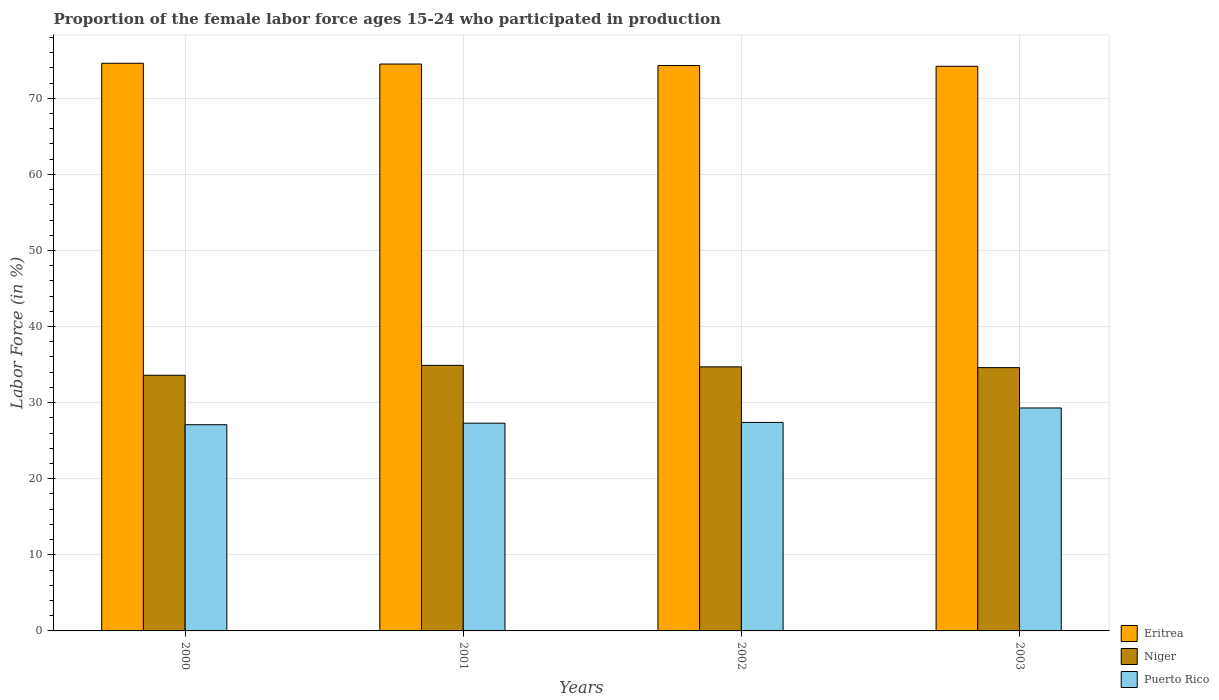How many groups of bars are there?
Make the answer very short. 4. Are the number of bars on each tick of the X-axis equal?
Offer a terse response. Yes. What is the label of the 4th group of bars from the left?
Your answer should be compact. 2003. What is the proportion of the female labor force who participated in production in Niger in 2000?
Offer a very short reply. 33.6. Across all years, what is the maximum proportion of the female labor force who participated in production in Eritrea?
Your response must be concise. 74.6. Across all years, what is the minimum proportion of the female labor force who participated in production in Puerto Rico?
Offer a very short reply. 27.1. What is the total proportion of the female labor force who participated in production in Puerto Rico in the graph?
Provide a short and direct response. 111.1. What is the difference between the proportion of the female labor force who participated in production in Niger in 2000 and that in 2003?
Give a very brief answer. -1. What is the difference between the proportion of the female labor force who participated in production in Puerto Rico in 2003 and the proportion of the female labor force who participated in production in Eritrea in 2002?
Give a very brief answer. -45. What is the average proportion of the female labor force who participated in production in Puerto Rico per year?
Your response must be concise. 27.77. In the year 2002, what is the difference between the proportion of the female labor force who participated in production in Puerto Rico and proportion of the female labor force who participated in production in Eritrea?
Give a very brief answer. -46.9. In how many years, is the proportion of the female labor force who participated in production in Niger greater than 32 %?
Keep it short and to the point. 4. What is the ratio of the proportion of the female labor force who participated in production in Eritrea in 2000 to that in 2002?
Ensure brevity in your answer.  1. What is the difference between the highest and the second highest proportion of the female labor force who participated in production in Niger?
Give a very brief answer. 0.2. What is the difference between the highest and the lowest proportion of the female labor force who participated in production in Niger?
Ensure brevity in your answer.  1.3. In how many years, is the proportion of the female labor force who participated in production in Eritrea greater than the average proportion of the female labor force who participated in production in Eritrea taken over all years?
Provide a succinct answer. 2. Is the sum of the proportion of the female labor force who participated in production in Niger in 2000 and 2002 greater than the maximum proportion of the female labor force who participated in production in Eritrea across all years?
Offer a terse response. No. What does the 3rd bar from the left in 2003 represents?
Your answer should be compact. Puerto Rico. What does the 2nd bar from the right in 2002 represents?
Offer a very short reply. Niger. Where does the legend appear in the graph?
Offer a terse response. Bottom right. What is the title of the graph?
Offer a very short reply. Proportion of the female labor force ages 15-24 who participated in production. What is the Labor Force (in %) of Eritrea in 2000?
Make the answer very short. 74.6. What is the Labor Force (in %) in Niger in 2000?
Provide a short and direct response. 33.6. What is the Labor Force (in %) of Puerto Rico in 2000?
Your answer should be compact. 27.1. What is the Labor Force (in %) in Eritrea in 2001?
Offer a terse response. 74.5. What is the Labor Force (in %) in Niger in 2001?
Provide a succinct answer. 34.9. What is the Labor Force (in %) of Puerto Rico in 2001?
Keep it short and to the point. 27.3. What is the Labor Force (in %) in Eritrea in 2002?
Ensure brevity in your answer.  74.3. What is the Labor Force (in %) in Niger in 2002?
Give a very brief answer. 34.7. What is the Labor Force (in %) in Puerto Rico in 2002?
Provide a short and direct response. 27.4. What is the Labor Force (in %) in Eritrea in 2003?
Offer a very short reply. 74.2. What is the Labor Force (in %) in Niger in 2003?
Your response must be concise. 34.6. What is the Labor Force (in %) in Puerto Rico in 2003?
Offer a terse response. 29.3. Across all years, what is the maximum Labor Force (in %) of Eritrea?
Keep it short and to the point. 74.6. Across all years, what is the maximum Labor Force (in %) of Niger?
Your answer should be compact. 34.9. Across all years, what is the maximum Labor Force (in %) in Puerto Rico?
Offer a terse response. 29.3. Across all years, what is the minimum Labor Force (in %) in Eritrea?
Offer a terse response. 74.2. Across all years, what is the minimum Labor Force (in %) in Niger?
Give a very brief answer. 33.6. Across all years, what is the minimum Labor Force (in %) of Puerto Rico?
Provide a short and direct response. 27.1. What is the total Labor Force (in %) of Eritrea in the graph?
Your answer should be compact. 297.6. What is the total Labor Force (in %) in Niger in the graph?
Keep it short and to the point. 137.8. What is the total Labor Force (in %) in Puerto Rico in the graph?
Provide a succinct answer. 111.1. What is the difference between the Labor Force (in %) of Eritrea in 2000 and that in 2001?
Your answer should be compact. 0.1. What is the difference between the Labor Force (in %) of Niger in 2000 and that in 2001?
Keep it short and to the point. -1.3. What is the difference between the Labor Force (in %) of Puerto Rico in 2000 and that in 2001?
Ensure brevity in your answer.  -0.2. What is the difference between the Labor Force (in %) of Eritrea in 2000 and that in 2002?
Keep it short and to the point. 0.3. What is the difference between the Labor Force (in %) of Niger in 2000 and that in 2002?
Offer a very short reply. -1.1. What is the difference between the Labor Force (in %) of Eritrea in 2000 and that in 2003?
Your response must be concise. 0.4. What is the difference between the Labor Force (in %) of Puerto Rico in 2000 and that in 2003?
Offer a very short reply. -2.2. What is the difference between the Labor Force (in %) in Eritrea in 2001 and that in 2002?
Offer a very short reply. 0.2. What is the difference between the Labor Force (in %) of Niger in 2001 and that in 2002?
Give a very brief answer. 0.2. What is the difference between the Labor Force (in %) of Puerto Rico in 2001 and that in 2002?
Provide a short and direct response. -0.1. What is the difference between the Labor Force (in %) in Puerto Rico in 2001 and that in 2003?
Your response must be concise. -2. What is the difference between the Labor Force (in %) of Niger in 2002 and that in 2003?
Your response must be concise. 0.1. What is the difference between the Labor Force (in %) in Puerto Rico in 2002 and that in 2003?
Your answer should be very brief. -1.9. What is the difference between the Labor Force (in %) in Eritrea in 2000 and the Labor Force (in %) in Niger in 2001?
Provide a short and direct response. 39.7. What is the difference between the Labor Force (in %) of Eritrea in 2000 and the Labor Force (in %) of Puerto Rico in 2001?
Make the answer very short. 47.3. What is the difference between the Labor Force (in %) in Niger in 2000 and the Labor Force (in %) in Puerto Rico in 2001?
Ensure brevity in your answer.  6.3. What is the difference between the Labor Force (in %) of Eritrea in 2000 and the Labor Force (in %) of Niger in 2002?
Keep it short and to the point. 39.9. What is the difference between the Labor Force (in %) in Eritrea in 2000 and the Labor Force (in %) in Puerto Rico in 2002?
Provide a succinct answer. 47.2. What is the difference between the Labor Force (in %) in Niger in 2000 and the Labor Force (in %) in Puerto Rico in 2002?
Make the answer very short. 6.2. What is the difference between the Labor Force (in %) in Eritrea in 2000 and the Labor Force (in %) in Puerto Rico in 2003?
Make the answer very short. 45.3. What is the difference between the Labor Force (in %) in Eritrea in 2001 and the Labor Force (in %) in Niger in 2002?
Provide a succinct answer. 39.8. What is the difference between the Labor Force (in %) in Eritrea in 2001 and the Labor Force (in %) in Puerto Rico in 2002?
Your answer should be compact. 47.1. What is the difference between the Labor Force (in %) of Eritrea in 2001 and the Labor Force (in %) of Niger in 2003?
Your answer should be compact. 39.9. What is the difference between the Labor Force (in %) in Eritrea in 2001 and the Labor Force (in %) in Puerto Rico in 2003?
Keep it short and to the point. 45.2. What is the difference between the Labor Force (in %) in Eritrea in 2002 and the Labor Force (in %) in Niger in 2003?
Give a very brief answer. 39.7. What is the difference between the Labor Force (in %) in Eritrea in 2002 and the Labor Force (in %) in Puerto Rico in 2003?
Give a very brief answer. 45. What is the average Labor Force (in %) of Eritrea per year?
Your answer should be compact. 74.4. What is the average Labor Force (in %) in Niger per year?
Give a very brief answer. 34.45. What is the average Labor Force (in %) in Puerto Rico per year?
Keep it short and to the point. 27.77. In the year 2000, what is the difference between the Labor Force (in %) in Eritrea and Labor Force (in %) in Puerto Rico?
Your response must be concise. 47.5. In the year 2000, what is the difference between the Labor Force (in %) of Niger and Labor Force (in %) of Puerto Rico?
Make the answer very short. 6.5. In the year 2001, what is the difference between the Labor Force (in %) of Eritrea and Labor Force (in %) of Niger?
Ensure brevity in your answer.  39.6. In the year 2001, what is the difference between the Labor Force (in %) in Eritrea and Labor Force (in %) in Puerto Rico?
Provide a succinct answer. 47.2. In the year 2001, what is the difference between the Labor Force (in %) in Niger and Labor Force (in %) in Puerto Rico?
Your answer should be very brief. 7.6. In the year 2002, what is the difference between the Labor Force (in %) of Eritrea and Labor Force (in %) of Niger?
Provide a short and direct response. 39.6. In the year 2002, what is the difference between the Labor Force (in %) of Eritrea and Labor Force (in %) of Puerto Rico?
Ensure brevity in your answer.  46.9. In the year 2003, what is the difference between the Labor Force (in %) of Eritrea and Labor Force (in %) of Niger?
Make the answer very short. 39.6. In the year 2003, what is the difference between the Labor Force (in %) of Eritrea and Labor Force (in %) of Puerto Rico?
Make the answer very short. 44.9. What is the ratio of the Labor Force (in %) of Niger in 2000 to that in 2001?
Provide a succinct answer. 0.96. What is the ratio of the Labor Force (in %) in Puerto Rico in 2000 to that in 2001?
Keep it short and to the point. 0.99. What is the ratio of the Labor Force (in %) of Eritrea in 2000 to that in 2002?
Keep it short and to the point. 1. What is the ratio of the Labor Force (in %) of Niger in 2000 to that in 2002?
Make the answer very short. 0.97. What is the ratio of the Labor Force (in %) in Puerto Rico in 2000 to that in 2002?
Your response must be concise. 0.99. What is the ratio of the Labor Force (in %) in Eritrea in 2000 to that in 2003?
Provide a succinct answer. 1.01. What is the ratio of the Labor Force (in %) of Niger in 2000 to that in 2003?
Keep it short and to the point. 0.97. What is the ratio of the Labor Force (in %) in Puerto Rico in 2000 to that in 2003?
Your answer should be compact. 0.92. What is the ratio of the Labor Force (in %) in Eritrea in 2001 to that in 2002?
Make the answer very short. 1. What is the ratio of the Labor Force (in %) of Niger in 2001 to that in 2003?
Offer a terse response. 1.01. What is the ratio of the Labor Force (in %) in Puerto Rico in 2001 to that in 2003?
Make the answer very short. 0.93. What is the ratio of the Labor Force (in %) in Eritrea in 2002 to that in 2003?
Keep it short and to the point. 1. What is the ratio of the Labor Force (in %) of Puerto Rico in 2002 to that in 2003?
Make the answer very short. 0.94. What is the difference between the highest and the lowest Labor Force (in %) of Puerto Rico?
Your answer should be very brief. 2.2. 